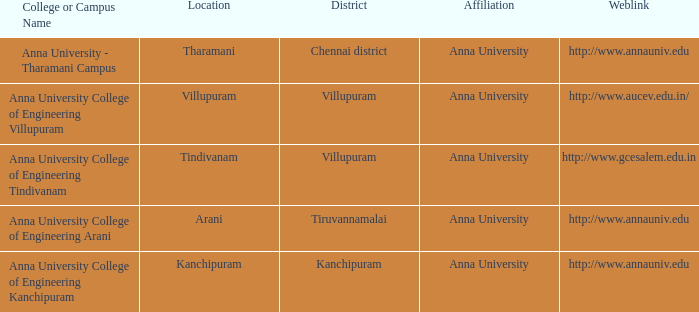Which district is home to the location of villupuram? Villupuram. 